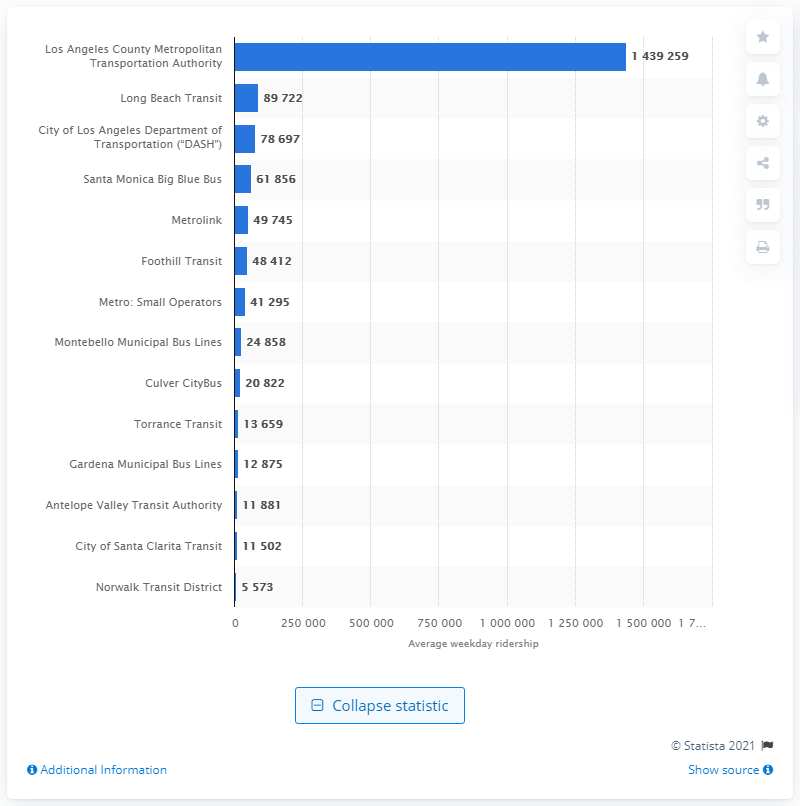Specify some key components in this picture. The Los Angeles County Metropolitan Transportation Authority provided a total of 143,925.9 rides each weekday. 